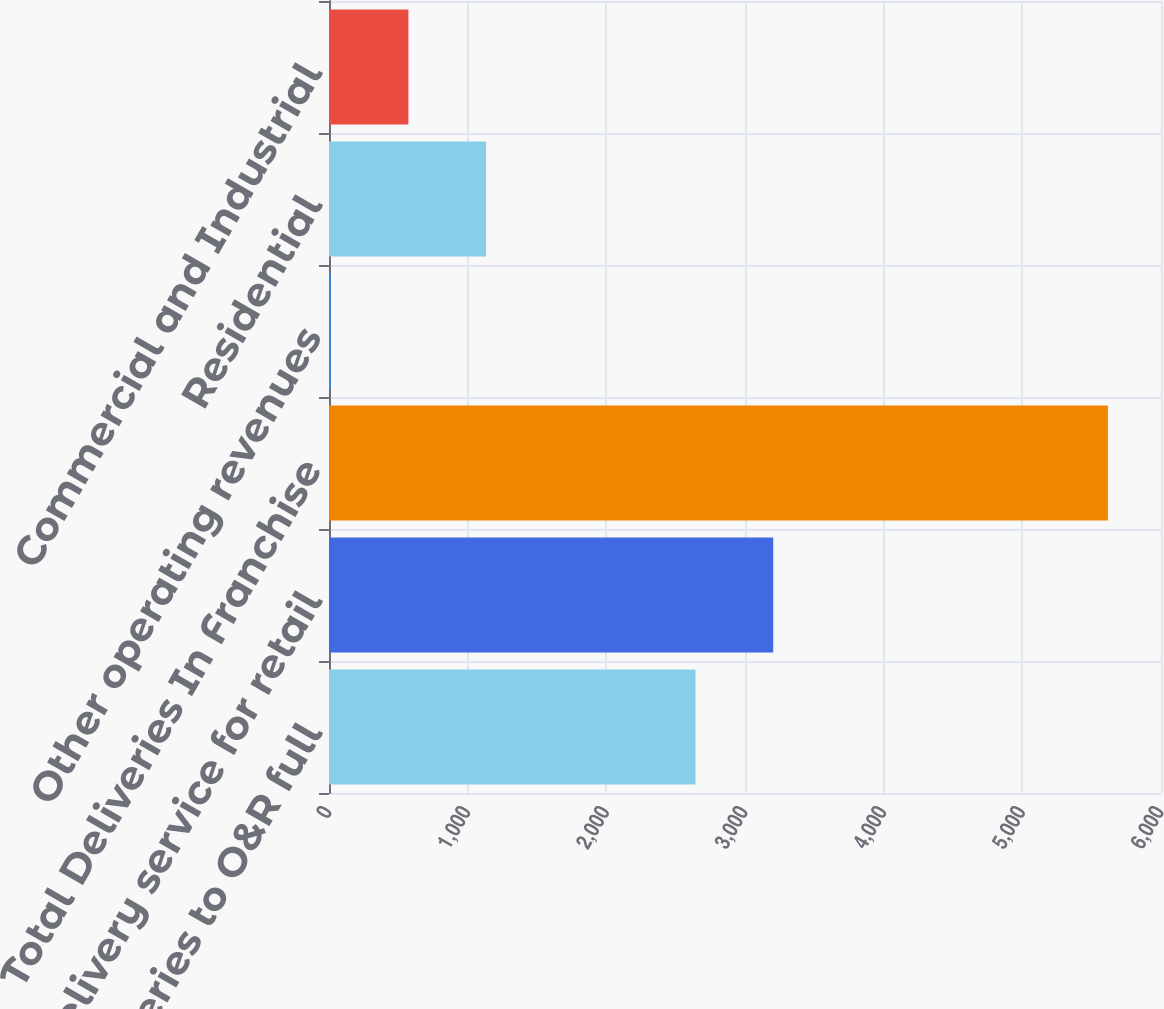Convert chart to OTSL. <chart><loc_0><loc_0><loc_500><loc_500><bar_chart><fcel>Total deliveries to O&R full<fcel>Delivery service for retail<fcel>Total Deliveries In Franchise<fcel>Other operating revenues<fcel>Residential<fcel>Commercial and Industrial<nl><fcel>2643<fcel>3203.5<fcel>5617<fcel>12<fcel>1133<fcel>572.5<nl></chart> 